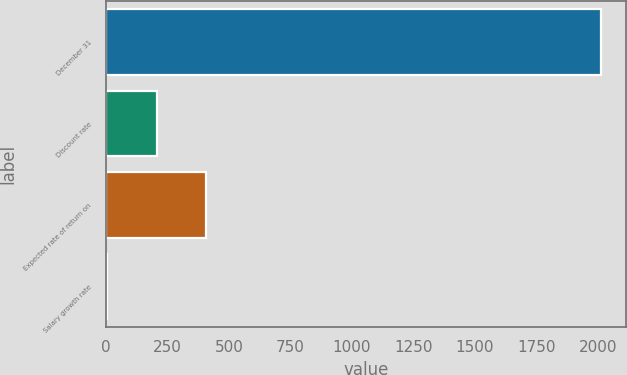Convert chart to OTSL. <chart><loc_0><loc_0><loc_500><loc_500><bar_chart><fcel>December 31<fcel>Discount rate<fcel>Expected rate of return on<fcel>Salary growth rate<nl><fcel>2014<fcel>205.45<fcel>406.4<fcel>4.5<nl></chart> 